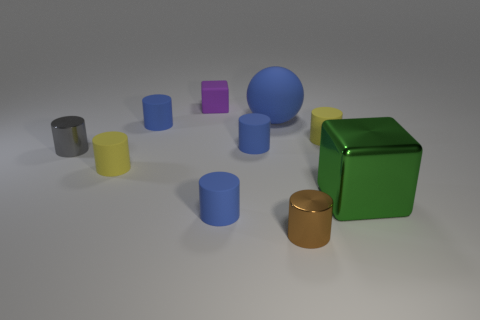How many blue cylinders must be subtracted to get 1 blue cylinders? 2 Subtract all cyan balls. How many blue cylinders are left? 3 Subtract 4 cylinders. How many cylinders are left? 3 Subtract all tiny shiny cylinders. How many cylinders are left? 5 Subtract all gray cylinders. How many cylinders are left? 6 Subtract all cyan cylinders. Subtract all cyan blocks. How many cylinders are left? 7 Subtract all blocks. How many objects are left? 8 Add 2 large brown shiny objects. How many large brown shiny objects exist? 2 Subtract 1 gray cylinders. How many objects are left? 9 Subtract all large purple balls. Subtract all brown shiny objects. How many objects are left? 9 